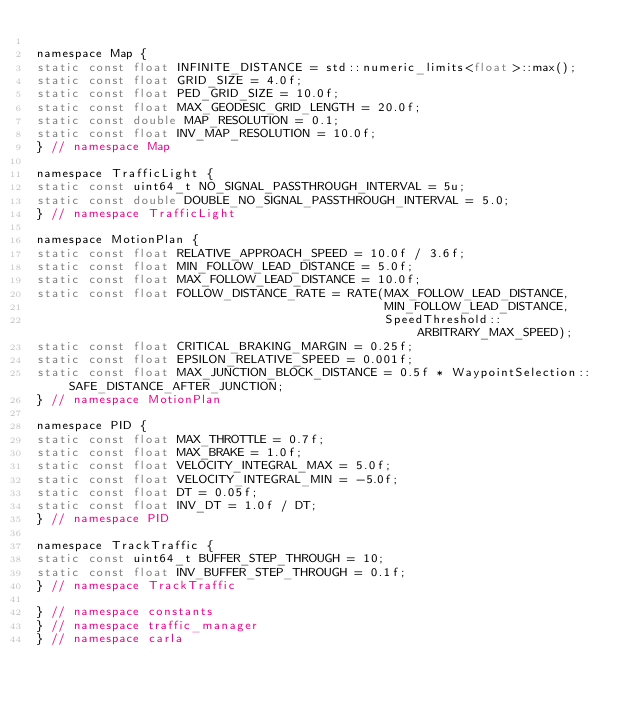Convert code to text. <code><loc_0><loc_0><loc_500><loc_500><_C_>
namespace Map {
static const float INFINITE_DISTANCE = std::numeric_limits<float>::max();
static const float GRID_SIZE = 4.0f;
static const float PED_GRID_SIZE = 10.0f;
static const float MAX_GEODESIC_GRID_LENGTH = 20.0f;
static const double MAP_RESOLUTION = 0.1;
static const float INV_MAP_RESOLUTION = 10.0f;
} // namespace Map

namespace TrafficLight {
static const uint64_t NO_SIGNAL_PASSTHROUGH_INTERVAL = 5u;
static const double DOUBLE_NO_SIGNAL_PASSTHROUGH_INTERVAL = 5.0;
} // namespace TrafficLight

namespace MotionPlan {
static const float RELATIVE_APPROACH_SPEED = 10.0f / 3.6f;
static const float MIN_FOLLOW_LEAD_DISTANCE = 5.0f;
static const float MAX_FOLLOW_LEAD_DISTANCE = 10.0f;
static const float FOLLOW_DISTANCE_RATE = RATE(MAX_FOLLOW_LEAD_DISTANCE,
                                               MIN_FOLLOW_LEAD_DISTANCE,
                                               SpeedThreshold::ARBITRARY_MAX_SPEED);
static const float CRITICAL_BRAKING_MARGIN = 0.25f;
static const float EPSILON_RELATIVE_SPEED = 0.001f;
static const float MAX_JUNCTION_BLOCK_DISTANCE = 0.5f * WaypointSelection::SAFE_DISTANCE_AFTER_JUNCTION;
} // namespace MotionPlan

namespace PID {
static const float MAX_THROTTLE = 0.7f;
static const float MAX_BRAKE = 1.0f;
static const float VELOCITY_INTEGRAL_MAX = 5.0f;
static const float VELOCITY_INTEGRAL_MIN = -5.0f;
static const float DT = 0.05f;
static const float INV_DT = 1.0f / DT;
} // namespace PID

namespace TrackTraffic {
static const uint64_t BUFFER_STEP_THROUGH = 10;
static const float INV_BUFFER_STEP_THROUGH = 0.1f;
} // namespace TrackTraffic

} // namespace constants
} // namespace traffic_manager
} // namespace carla
</code> 